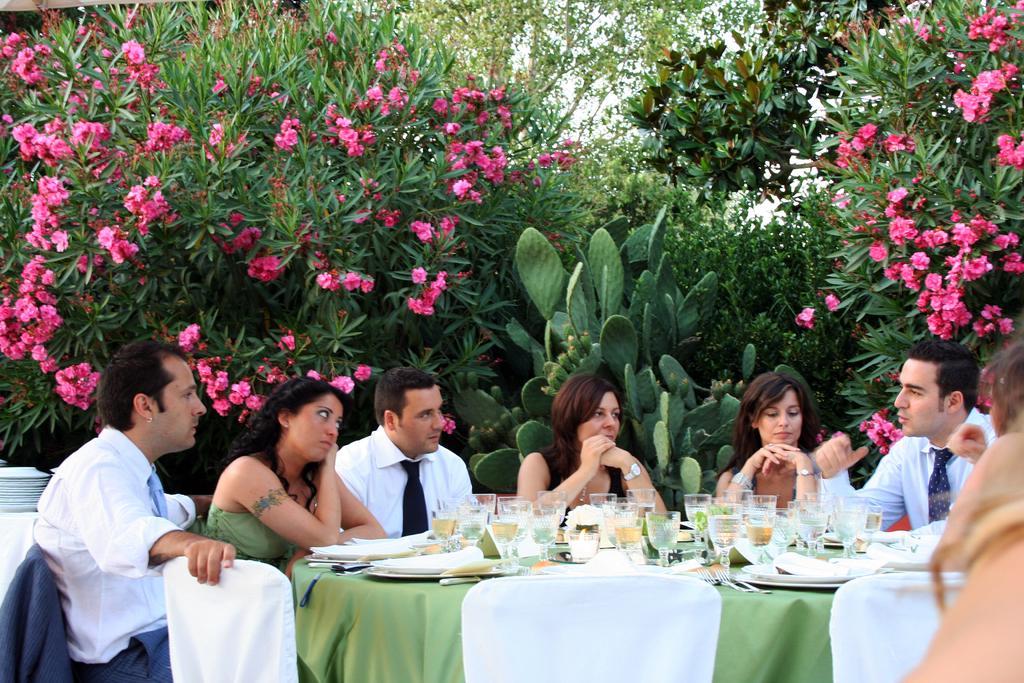How would you summarize this image in a sentence or two? As we can see in the image there are trees, flowers, few people sitting on chairs, table covered with green color cloth. On table there are plates and glasses. 